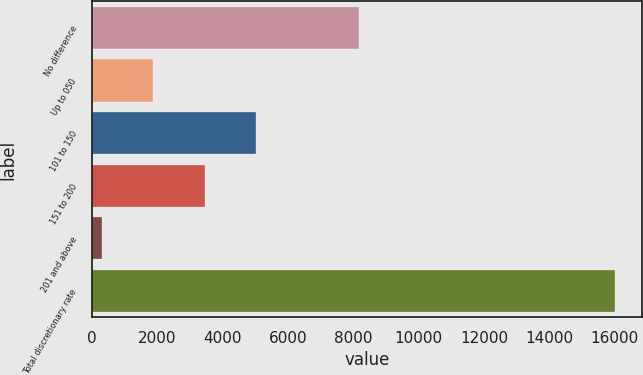Convert chart. <chart><loc_0><loc_0><loc_500><loc_500><bar_chart><fcel>No difference<fcel>Up to 050<fcel>101 to 150<fcel>151 to 200<fcel>201 and above<fcel>Total discretionary rate<nl><fcel>8180.1<fcel>1875.99<fcel>5018.77<fcel>3447.38<fcel>304.6<fcel>16018.5<nl></chart> 